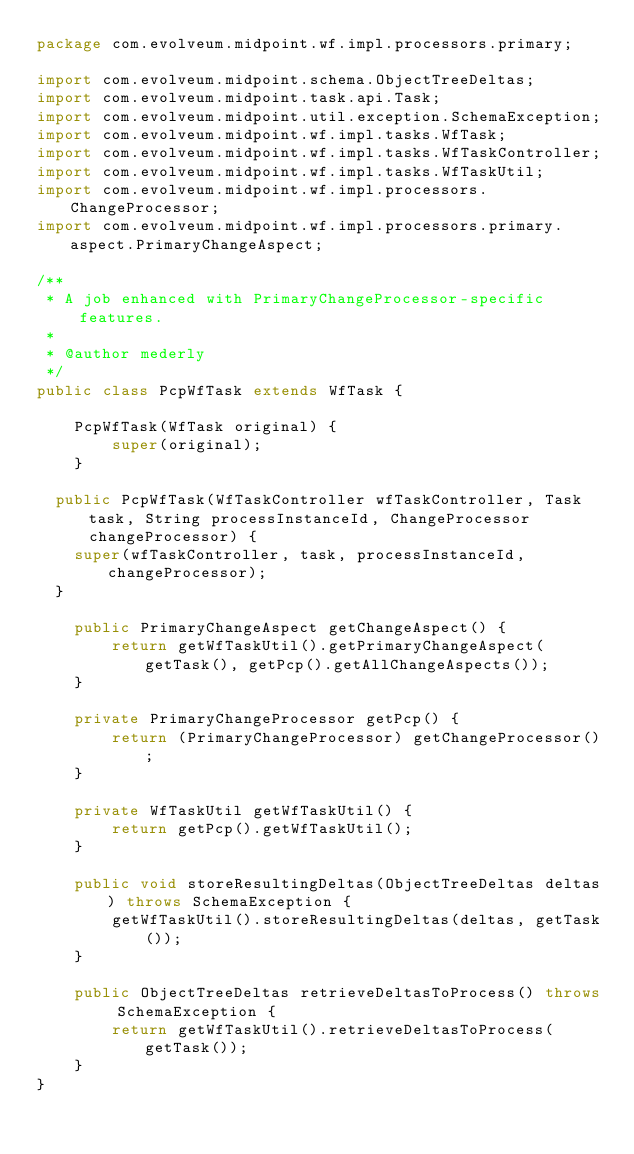<code> <loc_0><loc_0><loc_500><loc_500><_Java_>package com.evolveum.midpoint.wf.impl.processors.primary;

import com.evolveum.midpoint.schema.ObjectTreeDeltas;
import com.evolveum.midpoint.task.api.Task;
import com.evolveum.midpoint.util.exception.SchemaException;
import com.evolveum.midpoint.wf.impl.tasks.WfTask;
import com.evolveum.midpoint.wf.impl.tasks.WfTaskController;
import com.evolveum.midpoint.wf.impl.tasks.WfTaskUtil;
import com.evolveum.midpoint.wf.impl.processors.ChangeProcessor;
import com.evolveum.midpoint.wf.impl.processors.primary.aspect.PrimaryChangeAspect;

/**
 * A job enhanced with PrimaryChangeProcessor-specific features.
 *
 * @author mederly
 */
public class PcpWfTask extends WfTask {

    PcpWfTask(WfTask original) {
        super(original);
    }

	public PcpWfTask(WfTaskController wfTaskController, Task task, String processInstanceId, ChangeProcessor changeProcessor) {
		super(wfTaskController, task, processInstanceId, changeProcessor);
	}

    public PrimaryChangeAspect getChangeAspect() {
        return getWfTaskUtil().getPrimaryChangeAspect(getTask(), getPcp().getAllChangeAspects());
    }

    private PrimaryChangeProcessor getPcp() {
        return (PrimaryChangeProcessor) getChangeProcessor();
    }

    private WfTaskUtil getWfTaskUtil() {
        return getPcp().getWfTaskUtil();
    }

    public void storeResultingDeltas(ObjectTreeDeltas deltas) throws SchemaException {
        getWfTaskUtil().storeResultingDeltas(deltas, getTask());
    }

    public ObjectTreeDeltas retrieveDeltasToProcess() throws SchemaException {
        return getWfTaskUtil().retrieveDeltasToProcess(getTask());
    }
}
</code> 